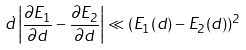<formula> <loc_0><loc_0><loc_500><loc_500>\dot { d } \left | \frac { \partial E _ { 1 } } { \partial d } - \frac { \partial E _ { 2 } } { \partial d } \right | \ll ( E _ { 1 } ( d ) - E _ { 2 } ( d ) ) ^ { 2 }</formula> 